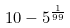<formula> <loc_0><loc_0><loc_500><loc_500>1 0 - 5 ^ { \frac { 1 } { 9 9 } }</formula> 